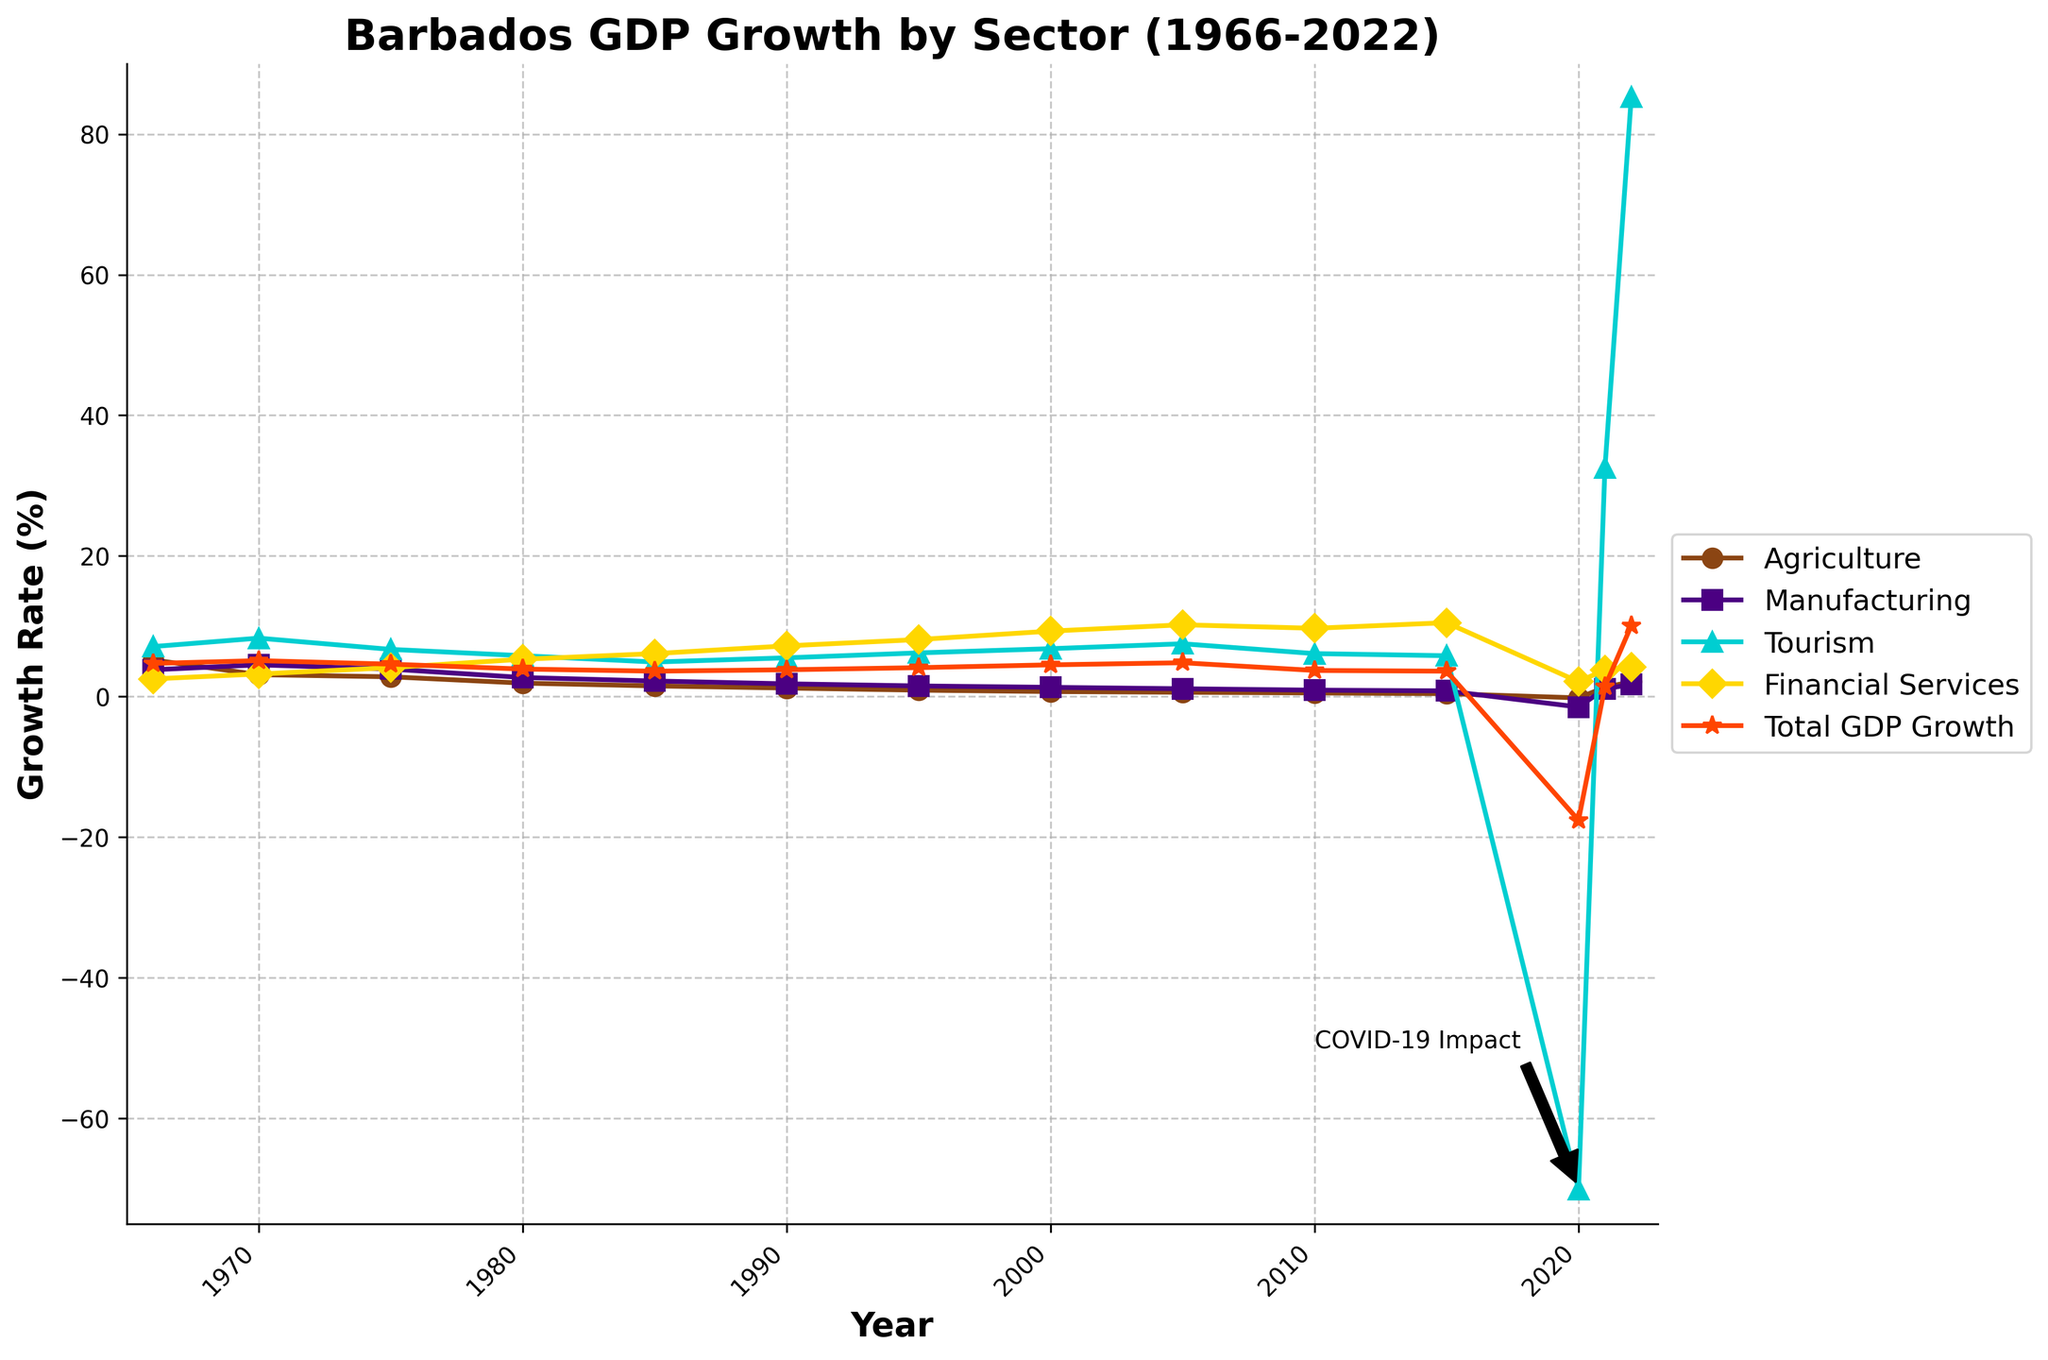What is the trend in the Agriculture sector from 1966 to 2022? The Agriculture sector shows a consistent decline from 5.2% in 1966 to around 0.4% in 2015, with a slight dip to -0.2% in 2020, rebounding to 2.1% by 2022.
Answer: Consistently declining Which sector experienced the most significant decline in any single year? Tourism experienced the most significant decline in 2020, dropping to -70.1% due to the impact of COVID-19.
Answer: Tourism in 2020 How did the Financial Services sector perform from 1966 to 2022? Financial Services consistently grew from 2.5% in 1966 to 10.5% in 2015, slightly reducing to 2.1% in 2020 during the pandemic before rebounding to 4.2% in 2022.
Answer: Consistently grew Compare the Total GDP Growth rate in 2020 and 2022. What is the difference? The Total GDP Growth rate was -17.6% in 2020 and improved to 10.1% in 2022. The difference is 10.1% - (-17.6%) = 27.7%.
Answer: 27.7% Which sector showed the highest growth rate in 2022? The Tourism sector showed the highest growth rate in 2022 at 85.3%.
Answer: Tourism How does the growth rate of Manufacturing in 1980 compare to that in 2022? The growth rate of Manufacturing was 2.7% in 1980 and slightly increased to 1.7% in 2022, indicating a general decline over the decades.
Answer: Declined What is the average growth rate of the Tourism sector from 1966 to 2019, excluding 2020 and beyond? Sum of Tourism growth rates from 1966 to 2019: 5.2 + 3.1 + 2.8 + 1.9 + 1.5 + 1.2 + 0.9 + 0.7 + 0.6 + 0.5 + 0.4 = 18.8%. Number of years = 11. Average = 18.8/11 = 1.71%
Answer: 1.71% Which year saw the lowest overall Total GDP Growth rate and what was its value? The lowest overall Total GDP Growth rate was in 2020, with a value of -17.6%.
Answer: 2020, -17.6% 